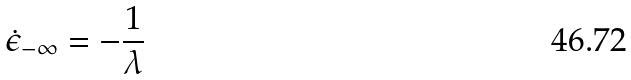<formula> <loc_0><loc_0><loc_500><loc_500>\dot { \epsilon } _ { - \infty } = - \frac { 1 } { \lambda }</formula> 